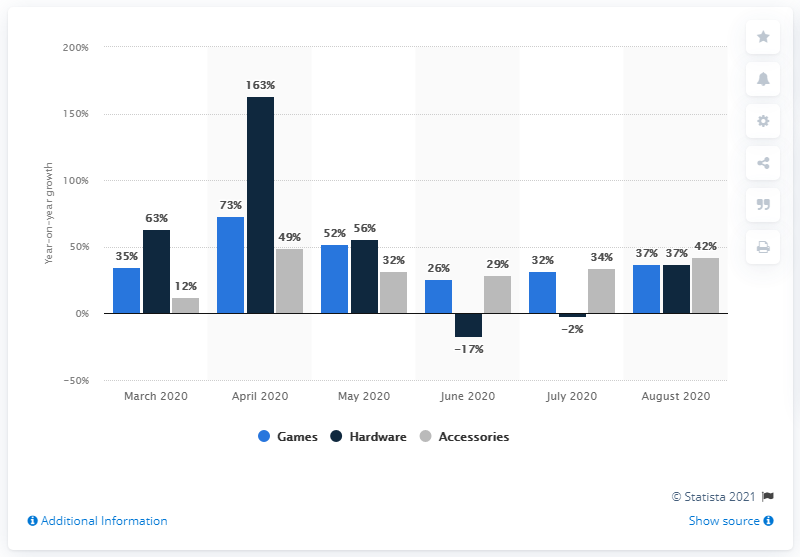Give some essential details in this illustration. In April of 2020, video gaming hardware sales in the United States increased by 163%. 